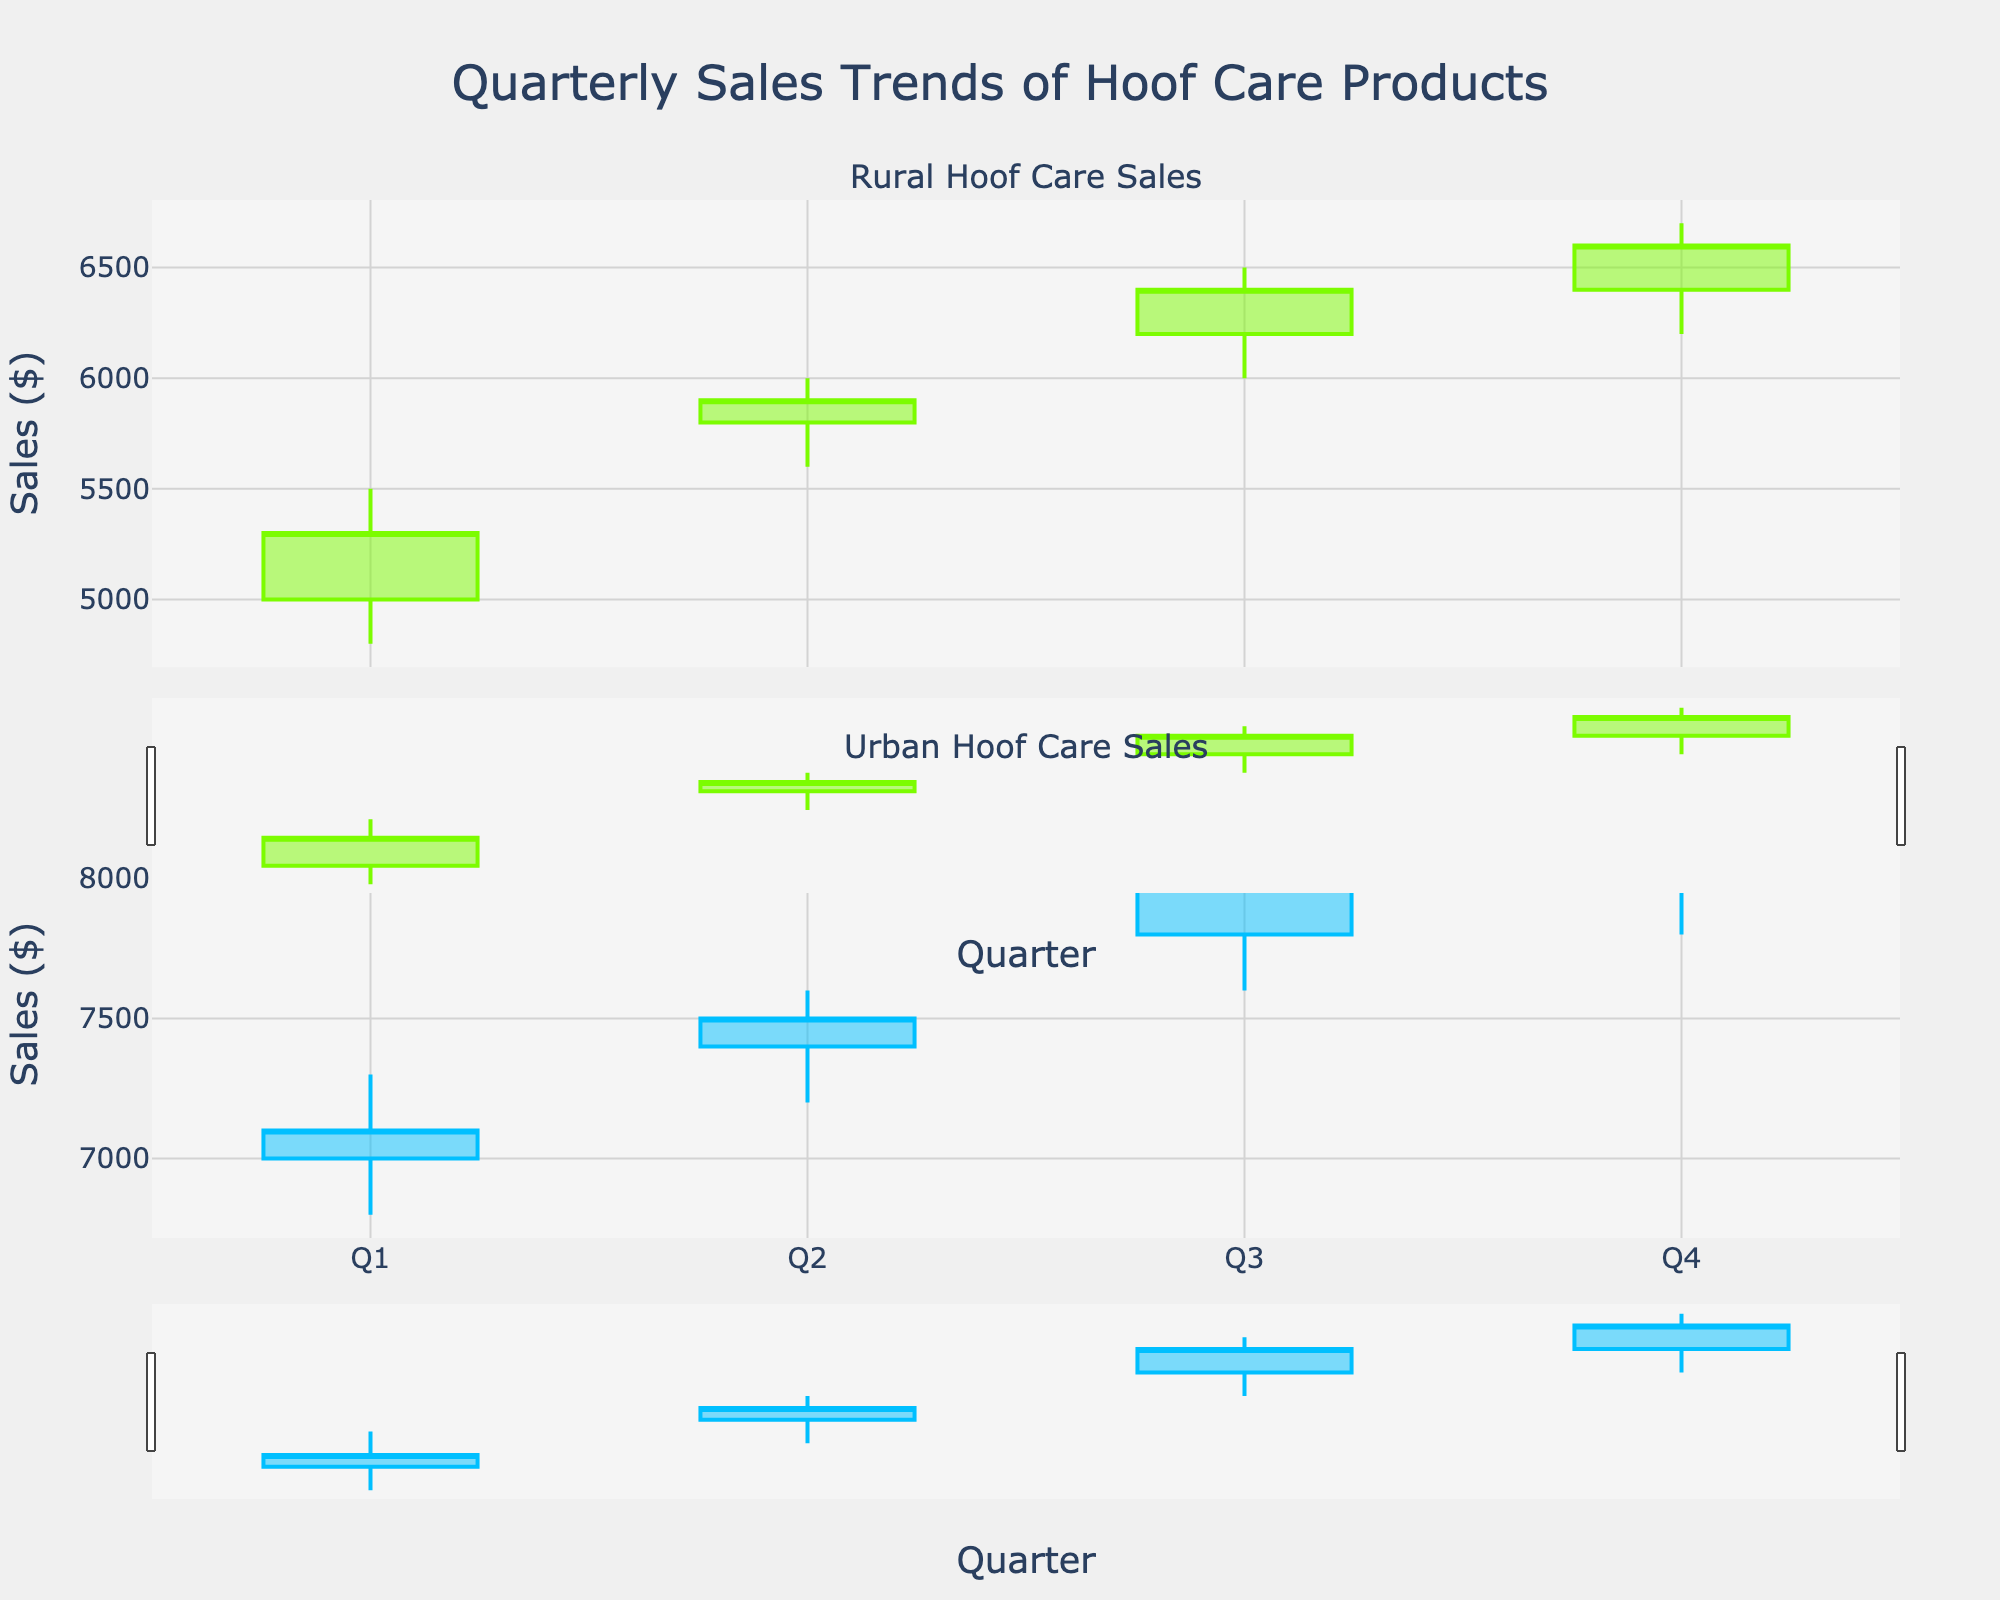What is the title of the figure? The title is located at the top of the figure and it reads "Quarterly Sales Trends of Hoof Care Products".
Answer: Quarterly Sales Trends of Hoof Care Products What are the two regions compared in the figure? The subplot titles indicate the two regions: "Rural Hoof Care Sales" and "Urban Hoof Care Sales".
Answer: Rural and Urban Which quarter had the highest closing sales in the Rural region? In the Rural region, the highest closing sales can be identified by the bar that ends at the highest point, which occurs in Q4 with a closing sale of 6600.
Answer: Q4 How do the Q1 opening sales compare between the Rural and Urban regions? In the Rural region, the Q1 opening sales are 5000. In the Urban region, the Q1 opening sales are 7000. 7000 is greater than 5000, so the Urban region has higher Q1 opening sales than the Rural region.
Answer: Urban had higher Q1 opening sales What is the average closing sales for the Rural region across all quarters? To find the average closing sales for the Rural region, sum all quarterly closing values: 5300, 5900, 6400, and 6600, which totals 24200. Divide this by 4 quarters: 24200 / 4 = 6050.
Answer: 6050 Which region shows an increasing trend in sales from Q1 to Q4? Both Rural and Urban regions show an increasing trend in their closing sales from Q1 to Q4. For Rural: 5300 to 6600. For Urban: 7100 to 8200. Both trends are upwards.
Answer: Both In which quarter did the Urban region experience the highest volatility in sales? Volatility in a candlestick plot can be judged by the distance between the high and low prices for that quarter. In the Urban region, Q3 has the highest volatility with a high of 8100 and a low of 7600, giving a range of 500.
Answer: Q3 What color represents increasing sales in the Urban region? Examining the candlestick bars for the Urban region, the color indicating increasing sales is light blue.
Answer: light blue What is the highest high value for the Urban region and in which quarter does it occur? Looking at the high values in the Urban region, the highest is 8300, which occurs in Q4.
Answer: 8300 in Q4 Compare the lowest low values of both regions. Which region had a lower low and in which quarter? For the Rural region, the lowest low value is 4800 in Q1. For the Urban region, the lowest low value is 6800 in Q1. 4800 in Rural is lower than 6800 in Urban.
Answer: Rural in Q1 